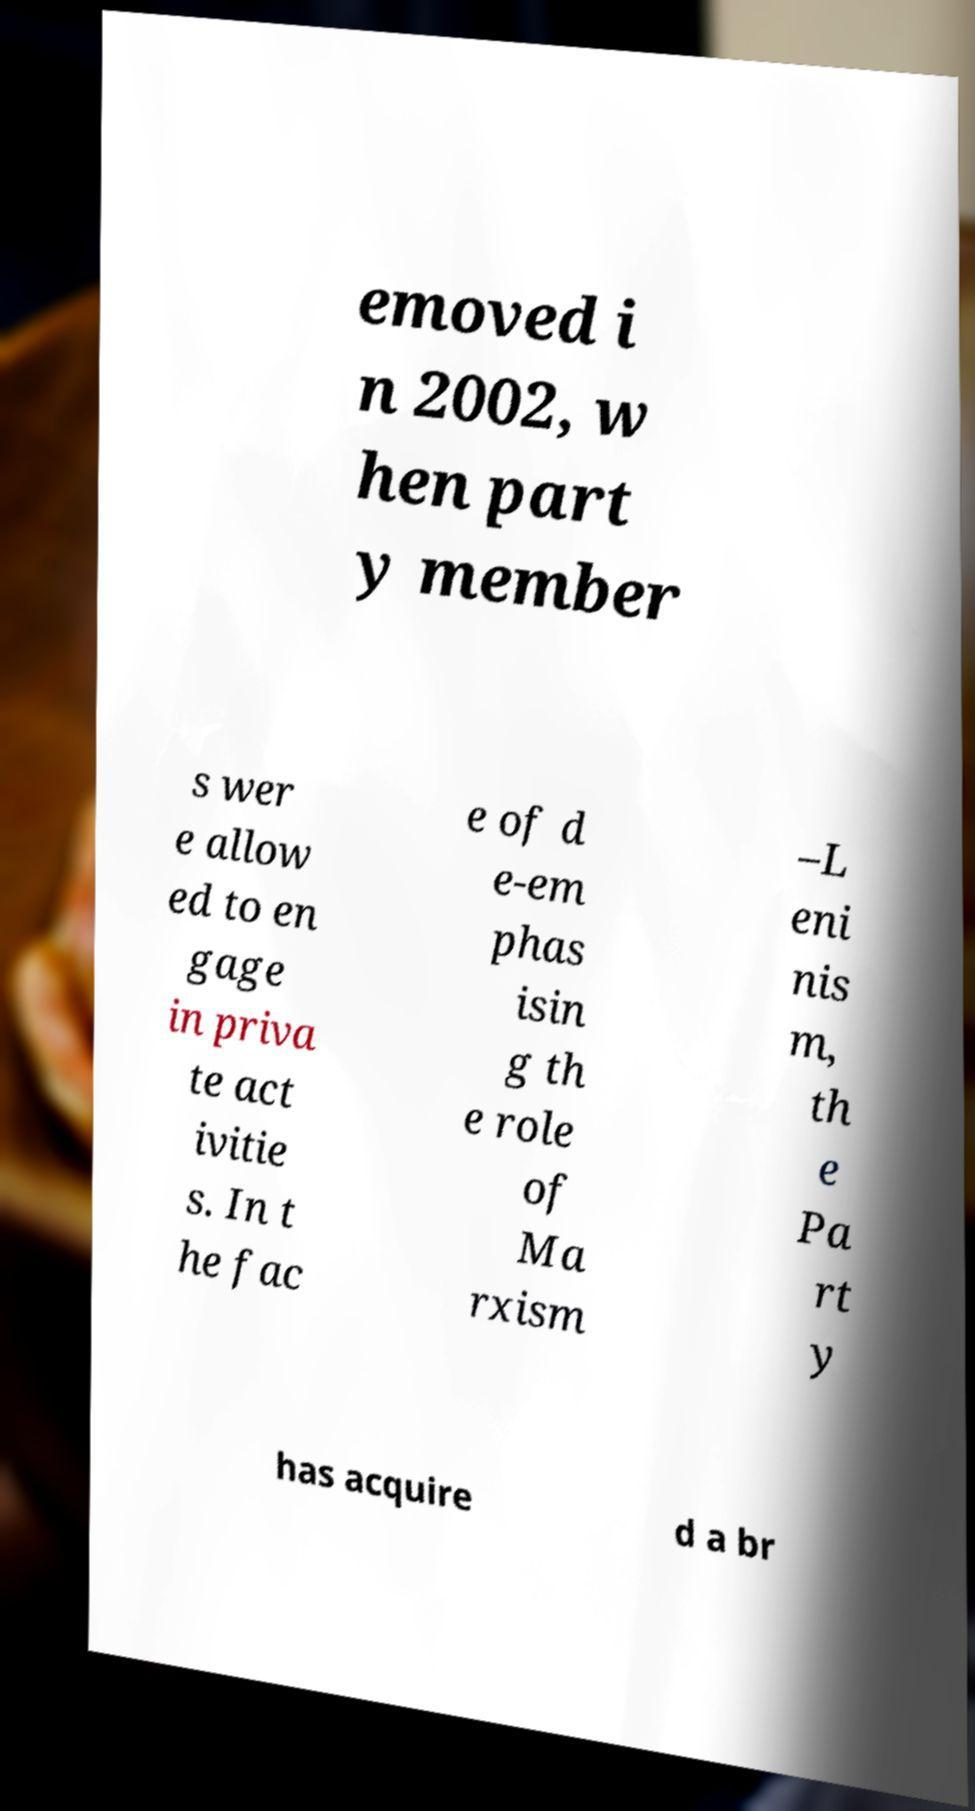Please identify and transcribe the text found in this image. emoved i n 2002, w hen part y member s wer e allow ed to en gage in priva te act ivitie s. In t he fac e of d e-em phas isin g th e role of Ma rxism –L eni nis m, th e Pa rt y has acquire d a br 